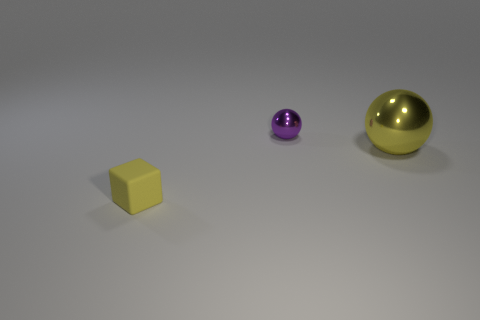Is there anything else that has the same size as the yellow metal sphere?
Your answer should be compact. No. There is a thing that is behind the tiny block and in front of the small sphere; what is its size?
Offer a terse response. Large. There is a small purple sphere; what number of purple metallic things are left of it?
Your response must be concise. 0. What is the shape of the thing that is in front of the small purple thing and behind the small block?
Your answer should be very brief. Sphere. There is a tiny block that is the same color as the large ball; what is it made of?
Your response must be concise. Rubber. What number of cylinders are red matte things or tiny purple things?
Your answer should be compact. 0. What size is the metal thing that is the same color as the matte cube?
Offer a very short reply. Large. Are there fewer tiny yellow objects that are in front of the large yellow metallic ball than yellow shiny balls?
Your response must be concise. No. What is the color of the object that is both to the left of the big shiny ball and on the right side of the small rubber object?
Give a very brief answer. Purple. What number of other things are the same shape as the purple metal object?
Ensure brevity in your answer.  1. 